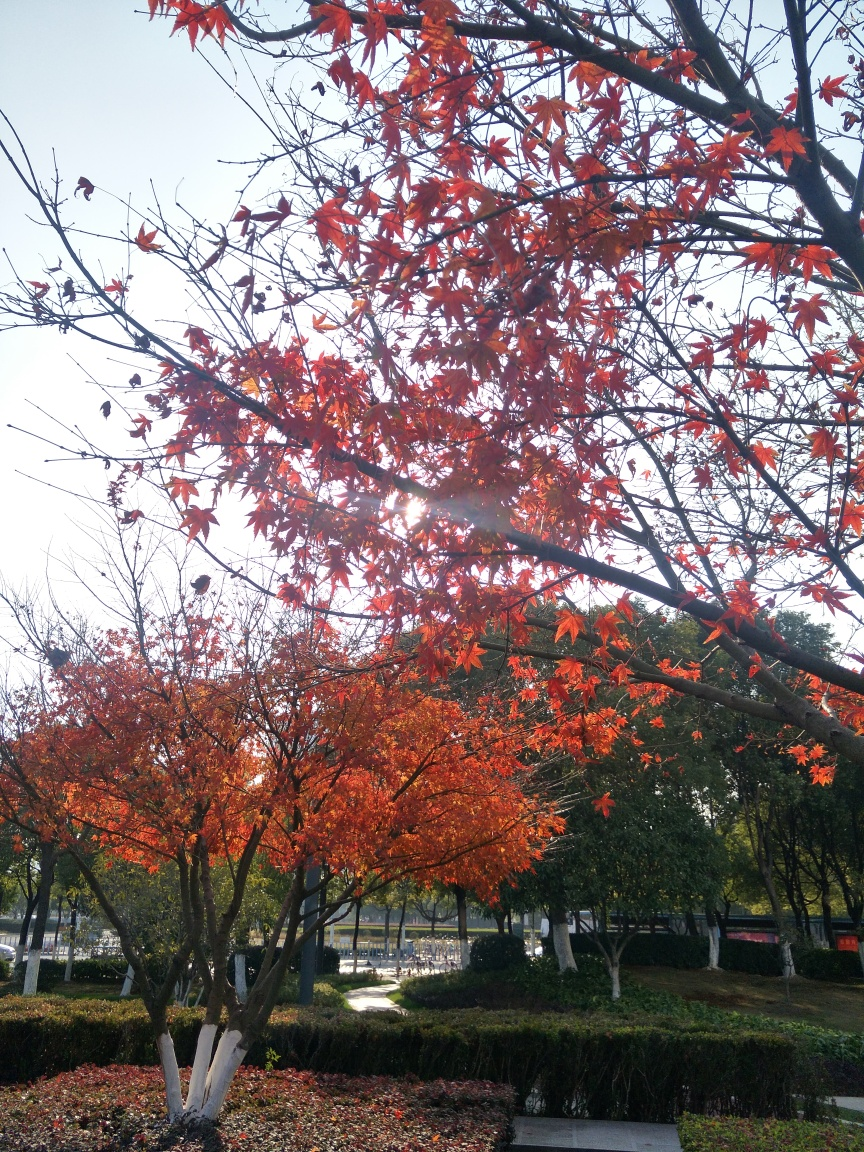What time of day does this photo seem to be taken? The long shadows and the warm, diffuse quality of the light suggest the photo was likely taken in the late afternoon. The sunlight's angle also implies that the day is waning and approaching evening. 